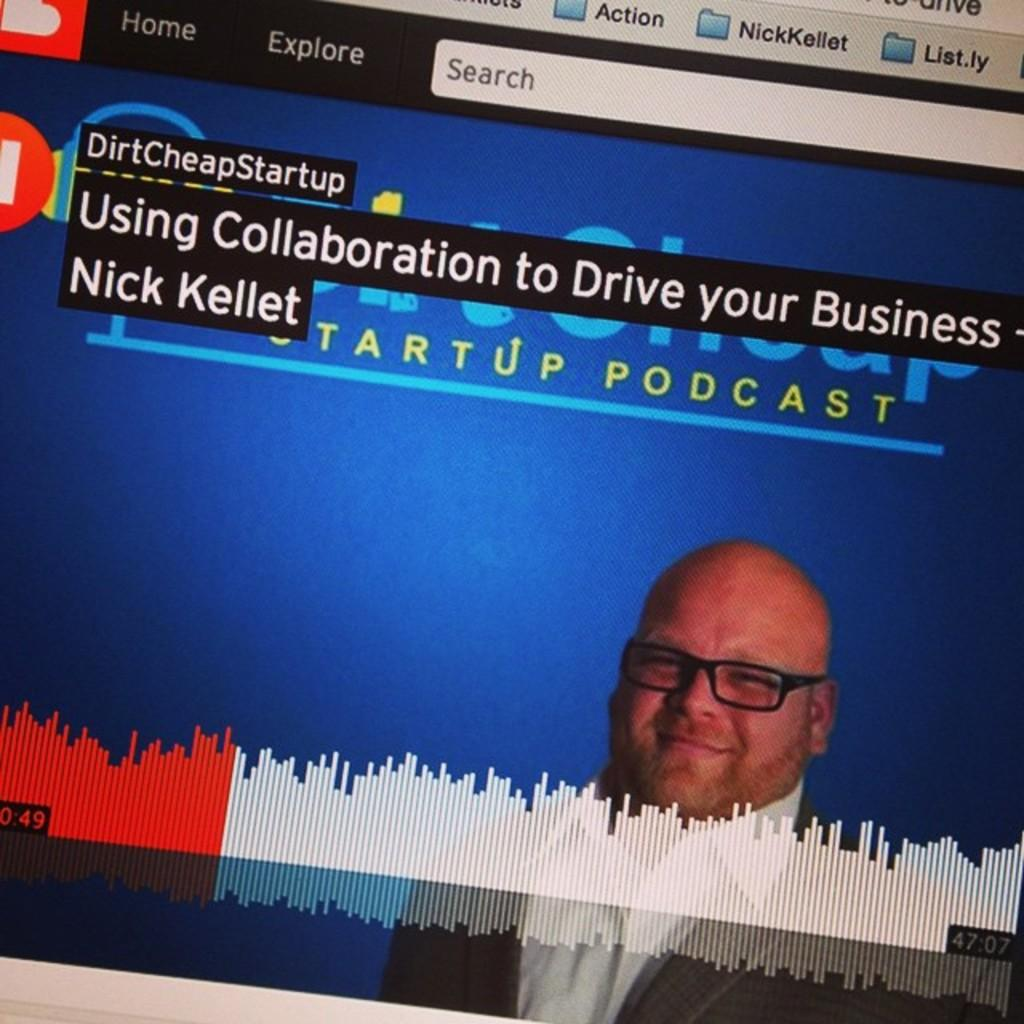What is the main subject of the image? The image contains a web page. Who is present on the web page? There is a man in the web page. What can be observed about the man's appearance? The man is wearing spectacles. What else can be found on the web page besides the man? There is text on the web page. How many pets can be seen in the image? There are no pets present in the image; it contains a web page with a man and text. What type of zipper is visible on the man's clothing in the image? There is no zipper visible on the man's clothing in the image; he is wearing spectacles. 